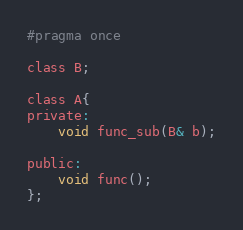Convert code to text. <code><loc_0><loc_0><loc_500><loc_500><_C_>#pragma once 

class B;

class A{
private:
	void func_sub(B& b);
	
public:
	void func();
};

</code> 